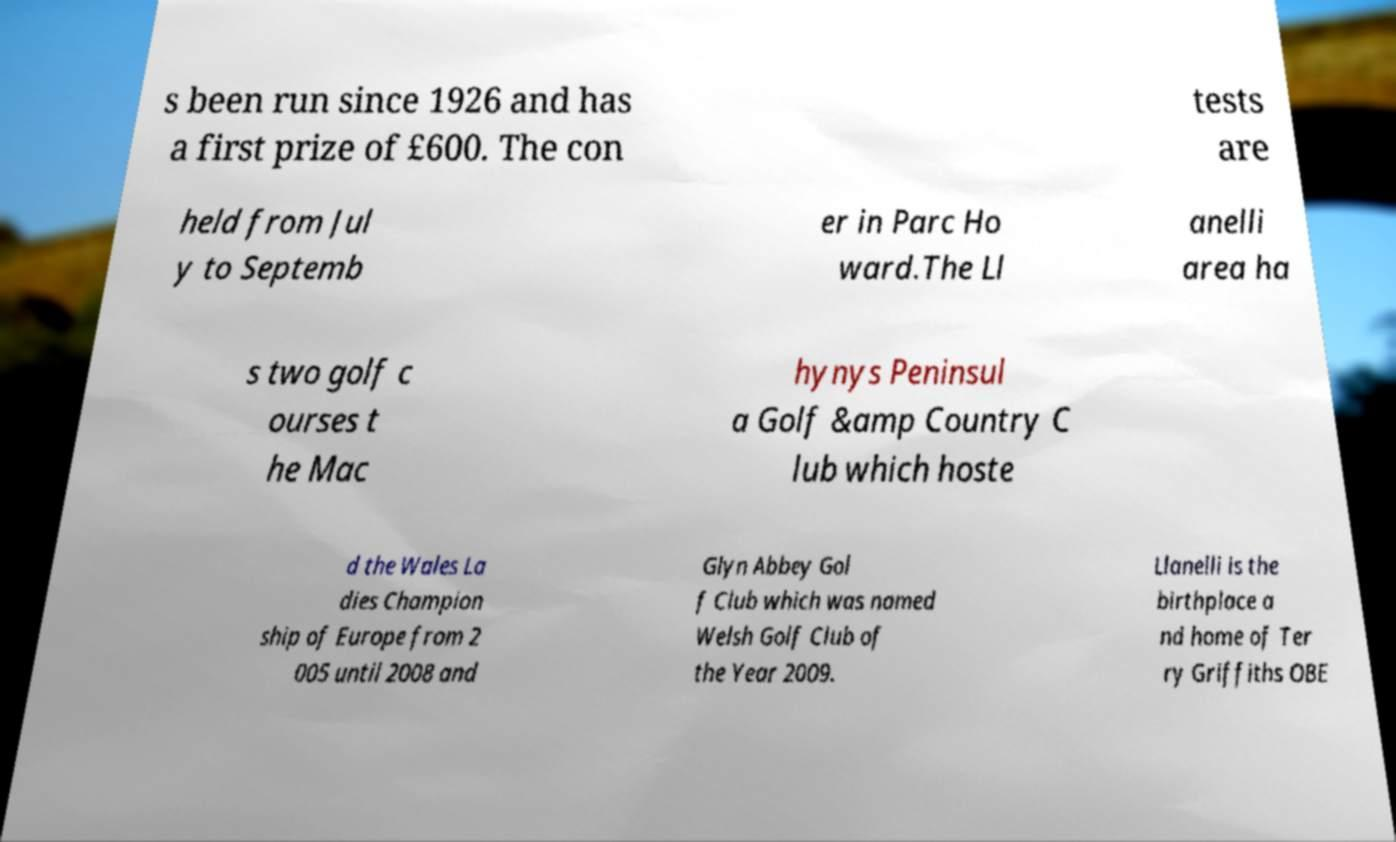What messages or text are displayed in this image? I need them in a readable, typed format. s been run since 1926 and has a first prize of £600. The con tests are held from Jul y to Septemb er in Parc Ho ward.The Ll anelli area ha s two golf c ourses t he Mac hynys Peninsul a Golf &amp Country C lub which hoste d the Wales La dies Champion ship of Europe from 2 005 until 2008 and Glyn Abbey Gol f Club which was named Welsh Golf Club of the Year 2009. Llanelli is the birthplace a nd home of Ter ry Griffiths OBE 